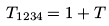Convert formula to latex. <formula><loc_0><loc_0><loc_500><loc_500>T _ { 1 2 3 4 } = 1 + T</formula> 